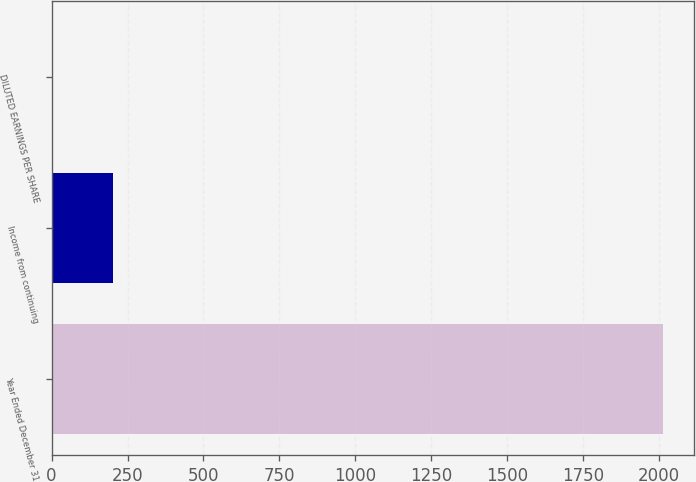<chart> <loc_0><loc_0><loc_500><loc_500><bar_chart><fcel>Year Ended December 31<fcel>Income from continuing<fcel>DILUTED EARNINGS PER SHARE<nl><fcel>2014<fcel>202.38<fcel>1.09<nl></chart> 